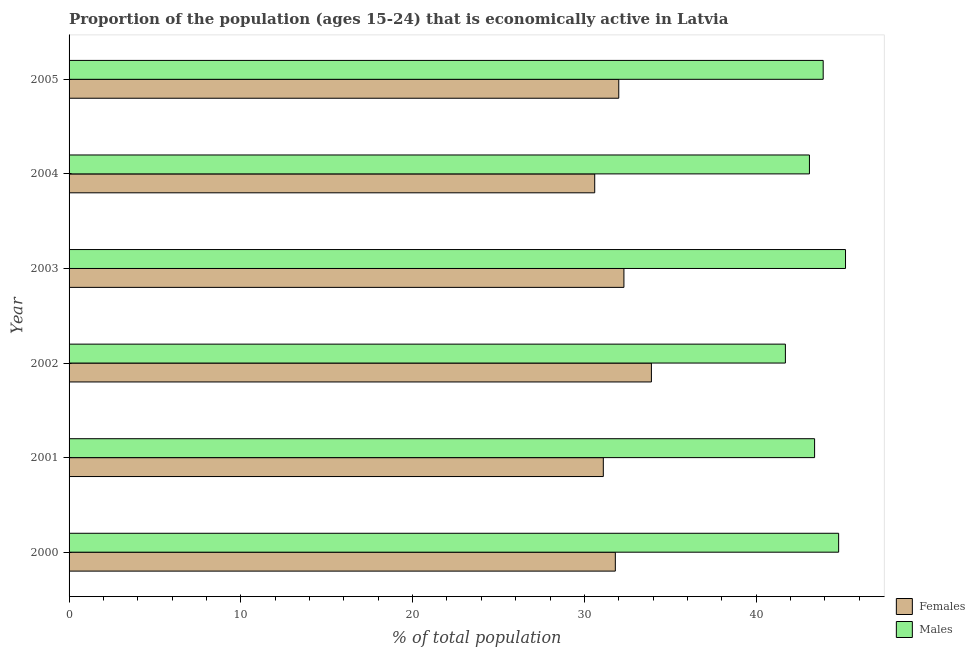How many different coloured bars are there?
Give a very brief answer. 2. How many groups of bars are there?
Your response must be concise. 6. Are the number of bars per tick equal to the number of legend labels?
Keep it short and to the point. Yes. How many bars are there on the 3rd tick from the bottom?
Provide a short and direct response. 2. What is the percentage of economically active female population in 2003?
Your answer should be very brief. 32.3. Across all years, what is the maximum percentage of economically active female population?
Offer a terse response. 33.9. Across all years, what is the minimum percentage of economically active female population?
Keep it short and to the point. 30.6. In which year was the percentage of economically active female population minimum?
Offer a very short reply. 2004. What is the total percentage of economically active female population in the graph?
Your answer should be very brief. 191.7. What is the difference between the percentage of economically active female population in 2003 and the percentage of economically active male population in 2005?
Provide a short and direct response. -11.6. What is the average percentage of economically active male population per year?
Your answer should be very brief. 43.68. In how many years, is the percentage of economically active female population greater than 36 %?
Your answer should be compact. 0. Is the percentage of economically active male population in 2000 less than that in 2004?
Offer a terse response. No. What is the difference between the highest and the second highest percentage of economically active female population?
Ensure brevity in your answer.  1.6. What is the difference between the highest and the lowest percentage of economically active male population?
Give a very brief answer. 3.5. Is the sum of the percentage of economically active female population in 2001 and 2005 greater than the maximum percentage of economically active male population across all years?
Provide a short and direct response. Yes. What does the 2nd bar from the top in 2001 represents?
Ensure brevity in your answer.  Females. What does the 1st bar from the bottom in 2002 represents?
Offer a very short reply. Females. Are all the bars in the graph horizontal?
Offer a terse response. Yes. How many years are there in the graph?
Keep it short and to the point. 6. Does the graph contain any zero values?
Make the answer very short. No. Does the graph contain grids?
Make the answer very short. No. What is the title of the graph?
Offer a terse response. Proportion of the population (ages 15-24) that is economically active in Latvia. What is the label or title of the X-axis?
Ensure brevity in your answer.  % of total population. What is the label or title of the Y-axis?
Your answer should be very brief. Year. What is the % of total population in Females in 2000?
Give a very brief answer. 31.8. What is the % of total population of Males in 2000?
Provide a short and direct response. 44.8. What is the % of total population in Females in 2001?
Make the answer very short. 31.1. What is the % of total population in Males in 2001?
Provide a succinct answer. 43.4. What is the % of total population in Females in 2002?
Offer a terse response. 33.9. What is the % of total population of Males in 2002?
Keep it short and to the point. 41.7. What is the % of total population of Females in 2003?
Keep it short and to the point. 32.3. What is the % of total population of Males in 2003?
Your answer should be very brief. 45.2. What is the % of total population in Females in 2004?
Provide a short and direct response. 30.6. What is the % of total population of Males in 2004?
Your response must be concise. 43.1. What is the % of total population of Females in 2005?
Make the answer very short. 32. What is the % of total population in Males in 2005?
Ensure brevity in your answer.  43.9. Across all years, what is the maximum % of total population of Females?
Ensure brevity in your answer.  33.9. Across all years, what is the maximum % of total population of Males?
Your answer should be compact. 45.2. Across all years, what is the minimum % of total population in Females?
Offer a terse response. 30.6. Across all years, what is the minimum % of total population in Males?
Offer a very short reply. 41.7. What is the total % of total population in Females in the graph?
Give a very brief answer. 191.7. What is the total % of total population of Males in the graph?
Offer a very short reply. 262.1. What is the difference between the % of total population in Females in 2000 and that in 2001?
Your response must be concise. 0.7. What is the difference between the % of total population in Females in 2000 and that in 2002?
Provide a succinct answer. -2.1. What is the difference between the % of total population of Males in 2000 and that in 2002?
Offer a terse response. 3.1. What is the difference between the % of total population in Females in 2000 and that in 2003?
Give a very brief answer. -0.5. What is the difference between the % of total population of Females in 2000 and that in 2004?
Your answer should be very brief. 1.2. What is the difference between the % of total population of Males in 2000 and that in 2004?
Your answer should be very brief. 1.7. What is the difference between the % of total population of Females in 2000 and that in 2005?
Provide a short and direct response. -0.2. What is the difference between the % of total population of Females in 2001 and that in 2002?
Make the answer very short. -2.8. What is the difference between the % of total population of Males in 2001 and that in 2002?
Your response must be concise. 1.7. What is the difference between the % of total population of Females in 2001 and that in 2004?
Your response must be concise. 0.5. What is the difference between the % of total population of Females in 2001 and that in 2005?
Keep it short and to the point. -0.9. What is the difference between the % of total population in Males in 2001 and that in 2005?
Give a very brief answer. -0.5. What is the difference between the % of total population in Females in 2002 and that in 2003?
Keep it short and to the point. 1.6. What is the difference between the % of total population in Males in 2002 and that in 2003?
Provide a succinct answer. -3.5. What is the difference between the % of total population in Females in 2002 and that in 2004?
Offer a terse response. 3.3. What is the difference between the % of total population of Females in 2002 and that in 2005?
Your response must be concise. 1.9. What is the difference between the % of total population in Females in 2003 and that in 2004?
Offer a very short reply. 1.7. What is the difference between the % of total population in Females in 2003 and that in 2005?
Your answer should be compact. 0.3. What is the difference between the % of total population of Males in 2003 and that in 2005?
Your answer should be very brief. 1.3. What is the difference between the % of total population in Females in 2004 and that in 2005?
Ensure brevity in your answer.  -1.4. What is the difference between the % of total population of Females in 2000 and the % of total population of Males in 2002?
Give a very brief answer. -9.9. What is the difference between the % of total population in Females in 2000 and the % of total population in Males in 2004?
Keep it short and to the point. -11.3. What is the difference between the % of total population in Females in 2000 and the % of total population in Males in 2005?
Your answer should be very brief. -12.1. What is the difference between the % of total population of Females in 2001 and the % of total population of Males in 2003?
Your response must be concise. -14.1. What is the difference between the % of total population of Females in 2002 and the % of total population of Males in 2003?
Offer a very short reply. -11.3. What is the difference between the % of total population of Females in 2002 and the % of total population of Males in 2004?
Your answer should be compact. -9.2. What is the difference between the % of total population in Females in 2004 and the % of total population in Males in 2005?
Your response must be concise. -13.3. What is the average % of total population of Females per year?
Make the answer very short. 31.95. What is the average % of total population of Males per year?
Ensure brevity in your answer.  43.68. In the year 2000, what is the difference between the % of total population in Females and % of total population in Males?
Give a very brief answer. -13. In the year 2004, what is the difference between the % of total population in Females and % of total population in Males?
Make the answer very short. -12.5. In the year 2005, what is the difference between the % of total population of Females and % of total population of Males?
Give a very brief answer. -11.9. What is the ratio of the % of total population of Females in 2000 to that in 2001?
Offer a terse response. 1.02. What is the ratio of the % of total population in Males in 2000 to that in 2001?
Offer a terse response. 1.03. What is the ratio of the % of total population of Females in 2000 to that in 2002?
Your response must be concise. 0.94. What is the ratio of the % of total population in Males in 2000 to that in 2002?
Your answer should be very brief. 1.07. What is the ratio of the % of total population in Females in 2000 to that in 2003?
Keep it short and to the point. 0.98. What is the ratio of the % of total population of Females in 2000 to that in 2004?
Offer a terse response. 1.04. What is the ratio of the % of total population in Males in 2000 to that in 2004?
Provide a succinct answer. 1.04. What is the ratio of the % of total population of Males in 2000 to that in 2005?
Keep it short and to the point. 1.02. What is the ratio of the % of total population in Females in 2001 to that in 2002?
Offer a very short reply. 0.92. What is the ratio of the % of total population of Males in 2001 to that in 2002?
Keep it short and to the point. 1.04. What is the ratio of the % of total population of Females in 2001 to that in 2003?
Your answer should be very brief. 0.96. What is the ratio of the % of total population in Males in 2001 to that in 2003?
Offer a very short reply. 0.96. What is the ratio of the % of total population of Females in 2001 to that in 2004?
Keep it short and to the point. 1.02. What is the ratio of the % of total population of Females in 2001 to that in 2005?
Your response must be concise. 0.97. What is the ratio of the % of total population in Females in 2002 to that in 2003?
Provide a short and direct response. 1.05. What is the ratio of the % of total population of Males in 2002 to that in 2003?
Ensure brevity in your answer.  0.92. What is the ratio of the % of total population in Females in 2002 to that in 2004?
Provide a succinct answer. 1.11. What is the ratio of the % of total population in Males in 2002 to that in 2004?
Provide a short and direct response. 0.97. What is the ratio of the % of total population in Females in 2002 to that in 2005?
Offer a terse response. 1.06. What is the ratio of the % of total population of Males in 2002 to that in 2005?
Provide a succinct answer. 0.95. What is the ratio of the % of total population of Females in 2003 to that in 2004?
Provide a short and direct response. 1.06. What is the ratio of the % of total population of Males in 2003 to that in 2004?
Keep it short and to the point. 1.05. What is the ratio of the % of total population of Females in 2003 to that in 2005?
Offer a very short reply. 1.01. What is the ratio of the % of total population in Males in 2003 to that in 2005?
Give a very brief answer. 1.03. What is the ratio of the % of total population in Females in 2004 to that in 2005?
Keep it short and to the point. 0.96. What is the ratio of the % of total population of Males in 2004 to that in 2005?
Your response must be concise. 0.98. What is the difference between the highest and the second highest % of total population in Females?
Your answer should be very brief. 1.6. What is the difference between the highest and the second highest % of total population of Males?
Your answer should be very brief. 0.4. 